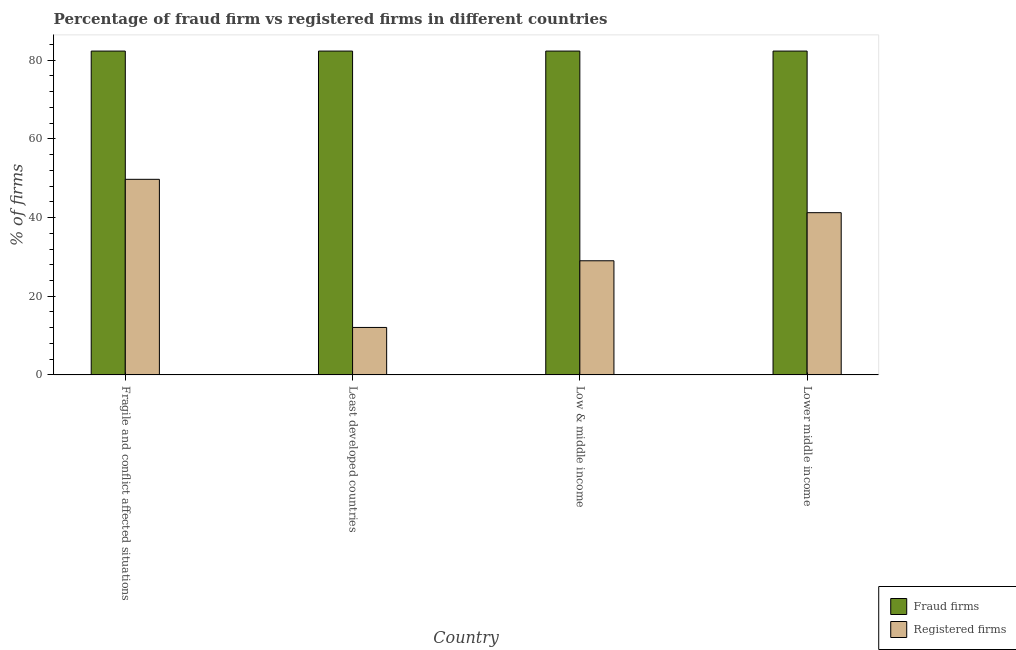How many different coloured bars are there?
Give a very brief answer. 2. Are the number of bars per tick equal to the number of legend labels?
Provide a short and direct response. Yes. How many bars are there on the 1st tick from the left?
Your response must be concise. 2. How many bars are there on the 3rd tick from the right?
Provide a short and direct response. 2. What is the label of the 1st group of bars from the left?
Your answer should be compact. Fragile and conflict affected situations. What is the percentage of fraud firms in Least developed countries?
Your answer should be compact. 82.33. Across all countries, what is the maximum percentage of registered firms?
Give a very brief answer. 49.72. Across all countries, what is the minimum percentage of fraud firms?
Keep it short and to the point. 82.33. In which country was the percentage of registered firms maximum?
Give a very brief answer. Fragile and conflict affected situations. In which country was the percentage of registered firms minimum?
Provide a short and direct response. Least developed countries. What is the total percentage of fraud firms in the graph?
Give a very brief answer. 329.32. What is the difference between the percentage of fraud firms in Lower middle income and the percentage of registered firms in Least developed countries?
Provide a short and direct response. 70.26. What is the average percentage of fraud firms per country?
Ensure brevity in your answer.  82.33. What is the difference between the percentage of registered firms and percentage of fraud firms in Low & middle income?
Provide a succinct answer. -53.31. In how many countries, is the percentage of fraud firms greater than 8 %?
Your answer should be compact. 4. What is the ratio of the percentage of fraud firms in Low & middle income to that in Lower middle income?
Offer a terse response. 1. Is the difference between the percentage of fraud firms in Least developed countries and Low & middle income greater than the difference between the percentage of registered firms in Least developed countries and Low & middle income?
Provide a short and direct response. Yes. What is the difference between the highest and the second highest percentage of registered firms?
Give a very brief answer. 8.48. What is the difference between the highest and the lowest percentage of fraud firms?
Provide a short and direct response. 0. Is the sum of the percentage of registered firms in Least developed countries and Low & middle income greater than the maximum percentage of fraud firms across all countries?
Ensure brevity in your answer.  No. What does the 1st bar from the left in Low & middle income represents?
Offer a very short reply. Fraud firms. What does the 2nd bar from the right in Least developed countries represents?
Provide a succinct answer. Fraud firms. Are all the bars in the graph horizontal?
Your response must be concise. No. Are the values on the major ticks of Y-axis written in scientific E-notation?
Give a very brief answer. No. Does the graph contain any zero values?
Ensure brevity in your answer.  No. Does the graph contain grids?
Make the answer very short. No. What is the title of the graph?
Ensure brevity in your answer.  Percentage of fraud firm vs registered firms in different countries. Does "Birth rate" appear as one of the legend labels in the graph?
Provide a succinct answer. No. What is the label or title of the X-axis?
Make the answer very short. Country. What is the label or title of the Y-axis?
Ensure brevity in your answer.  % of firms. What is the % of firms of Fraud firms in Fragile and conflict affected situations?
Give a very brief answer. 82.33. What is the % of firms in Registered firms in Fragile and conflict affected situations?
Ensure brevity in your answer.  49.72. What is the % of firms in Fraud firms in Least developed countries?
Offer a terse response. 82.33. What is the % of firms of Registered firms in Least developed countries?
Your answer should be very brief. 12.07. What is the % of firms of Fraud firms in Low & middle income?
Your answer should be very brief. 82.33. What is the % of firms of Registered firms in Low & middle income?
Your answer should be compact. 29.02. What is the % of firms in Fraud firms in Lower middle income?
Keep it short and to the point. 82.33. What is the % of firms in Registered firms in Lower middle income?
Keep it short and to the point. 41.24. Across all countries, what is the maximum % of firms in Fraud firms?
Keep it short and to the point. 82.33. Across all countries, what is the maximum % of firms in Registered firms?
Keep it short and to the point. 49.72. Across all countries, what is the minimum % of firms in Fraud firms?
Give a very brief answer. 82.33. Across all countries, what is the minimum % of firms of Registered firms?
Offer a very short reply. 12.07. What is the total % of firms of Fraud firms in the graph?
Keep it short and to the point. 329.32. What is the total % of firms of Registered firms in the graph?
Offer a terse response. 132.05. What is the difference between the % of firms in Registered firms in Fragile and conflict affected situations and that in Least developed countries?
Give a very brief answer. 37.66. What is the difference between the % of firms of Fraud firms in Fragile and conflict affected situations and that in Low & middle income?
Your answer should be very brief. 0. What is the difference between the % of firms in Registered firms in Fragile and conflict affected situations and that in Low & middle income?
Your answer should be very brief. 20.71. What is the difference between the % of firms in Registered firms in Fragile and conflict affected situations and that in Lower middle income?
Offer a very short reply. 8.48. What is the difference between the % of firms in Fraud firms in Least developed countries and that in Low & middle income?
Give a very brief answer. 0. What is the difference between the % of firms of Registered firms in Least developed countries and that in Low & middle income?
Make the answer very short. -16.95. What is the difference between the % of firms in Fraud firms in Least developed countries and that in Lower middle income?
Keep it short and to the point. 0. What is the difference between the % of firms of Registered firms in Least developed countries and that in Lower middle income?
Your answer should be compact. -29.18. What is the difference between the % of firms in Registered firms in Low & middle income and that in Lower middle income?
Your answer should be very brief. -12.23. What is the difference between the % of firms of Fraud firms in Fragile and conflict affected situations and the % of firms of Registered firms in Least developed countries?
Your answer should be very brief. 70.26. What is the difference between the % of firms in Fraud firms in Fragile and conflict affected situations and the % of firms in Registered firms in Low & middle income?
Offer a terse response. 53.31. What is the difference between the % of firms of Fraud firms in Fragile and conflict affected situations and the % of firms of Registered firms in Lower middle income?
Give a very brief answer. 41.09. What is the difference between the % of firms in Fraud firms in Least developed countries and the % of firms in Registered firms in Low & middle income?
Your answer should be very brief. 53.31. What is the difference between the % of firms in Fraud firms in Least developed countries and the % of firms in Registered firms in Lower middle income?
Make the answer very short. 41.09. What is the difference between the % of firms in Fraud firms in Low & middle income and the % of firms in Registered firms in Lower middle income?
Make the answer very short. 41.09. What is the average % of firms in Fraud firms per country?
Provide a short and direct response. 82.33. What is the average % of firms in Registered firms per country?
Offer a very short reply. 33.01. What is the difference between the % of firms of Fraud firms and % of firms of Registered firms in Fragile and conflict affected situations?
Provide a short and direct response. 32.61. What is the difference between the % of firms of Fraud firms and % of firms of Registered firms in Least developed countries?
Your answer should be very brief. 70.26. What is the difference between the % of firms in Fraud firms and % of firms in Registered firms in Low & middle income?
Provide a short and direct response. 53.31. What is the difference between the % of firms of Fraud firms and % of firms of Registered firms in Lower middle income?
Make the answer very short. 41.09. What is the ratio of the % of firms in Registered firms in Fragile and conflict affected situations to that in Least developed countries?
Ensure brevity in your answer.  4.12. What is the ratio of the % of firms in Registered firms in Fragile and conflict affected situations to that in Low & middle income?
Your answer should be compact. 1.71. What is the ratio of the % of firms of Fraud firms in Fragile and conflict affected situations to that in Lower middle income?
Your response must be concise. 1. What is the ratio of the % of firms in Registered firms in Fragile and conflict affected situations to that in Lower middle income?
Offer a very short reply. 1.21. What is the ratio of the % of firms in Fraud firms in Least developed countries to that in Low & middle income?
Your answer should be compact. 1. What is the ratio of the % of firms in Registered firms in Least developed countries to that in Low & middle income?
Provide a short and direct response. 0.42. What is the ratio of the % of firms in Fraud firms in Least developed countries to that in Lower middle income?
Keep it short and to the point. 1. What is the ratio of the % of firms of Registered firms in Least developed countries to that in Lower middle income?
Offer a terse response. 0.29. What is the ratio of the % of firms of Registered firms in Low & middle income to that in Lower middle income?
Give a very brief answer. 0.7. What is the difference between the highest and the second highest % of firms in Registered firms?
Ensure brevity in your answer.  8.48. What is the difference between the highest and the lowest % of firms of Registered firms?
Provide a short and direct response. 37.66. 